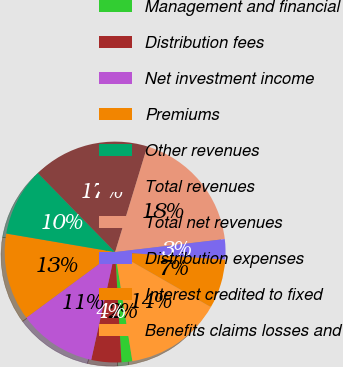Convert chart to OTSL. <chart><loc_0><loc_0><loc_500><loc_500><pie_chart><fcel>Management and financial<fcel>Distribution fees<fcel>Net investment income<fcel>Premiums<fcel>Other revenues<fcel>Total revenues<fcel>Total net revenues<fcel>Distribution expenses<fcel>Interest credited to fixed<fcel>Benefits claims losses and<nl><fcel>1.58%<fcel>4.39%<fcel>11.4%<fcel>12.81%<fcel>10.0%<fcel>17.02%<fcel>18.42%<fcel>2.98%<fcel>7.19%<fcel>14.21%<nl></chart> 